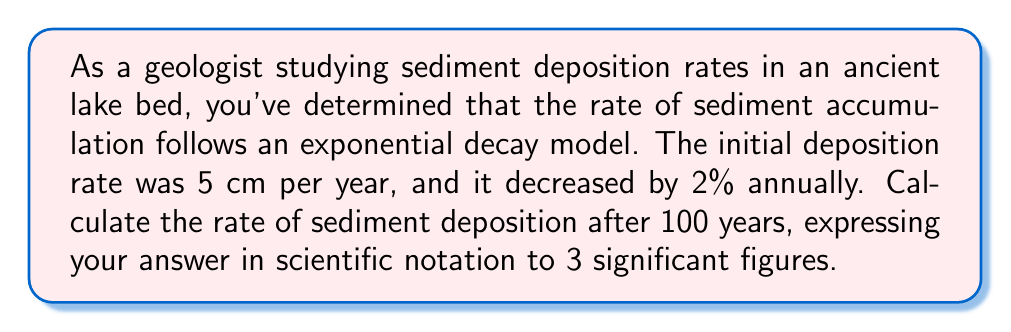Can you answer this question? Let's approach this step-by-step:

1) The exponential decay formula is:

   $$ A(t) = A_0 \cdot (1-r)^t $$

   Where:
   $A(t)$ is the amount at time $t$
   $A_0$ is the initial amount
   $r$ is the decay rate (as a decimal)
   $t$ is the time

2) In this case:
   $A_0 = 5$ cm/year (initial rate)
   $r = 0.02$ (2% decrease per year)
   $t = 100$ years

3) Plugging these values into the formula:

   $$ A(100) = 5 \cdot (1-0.02)^{100} $$

4) Simplify inside the parentheses:

   $$ A(100) = 5 \cdot (0.98)^{100} $$

5) Use a calculator to evaluate $(0.98)^{100}$:

   $$ A(100) = 5 \cdot 0.1326 $$

6) Multiply:

   $$ A(100) = 0.663 \text{ cm/year} $$

7) Express in scientific notation to 3 significant figures:

   $$ A(100) = 6.63 \times 10^{-1} \text{ cm/year} $$
Answer: $6.63 \times 10^{-1} \text{ cm/year}$ 